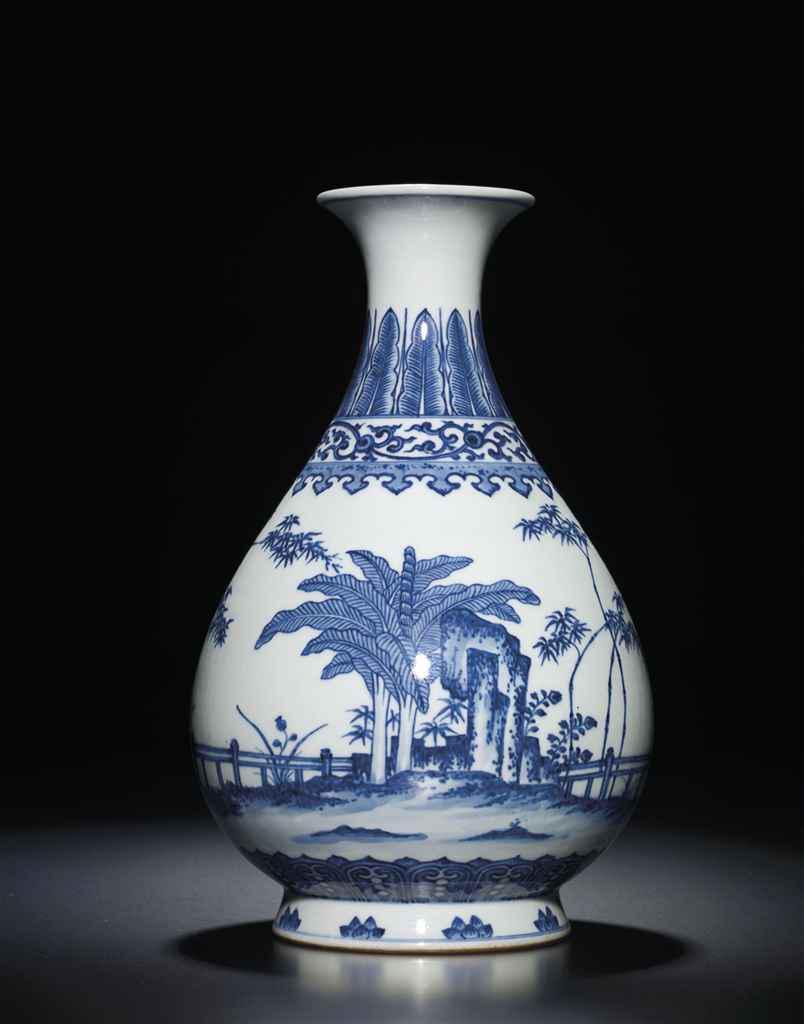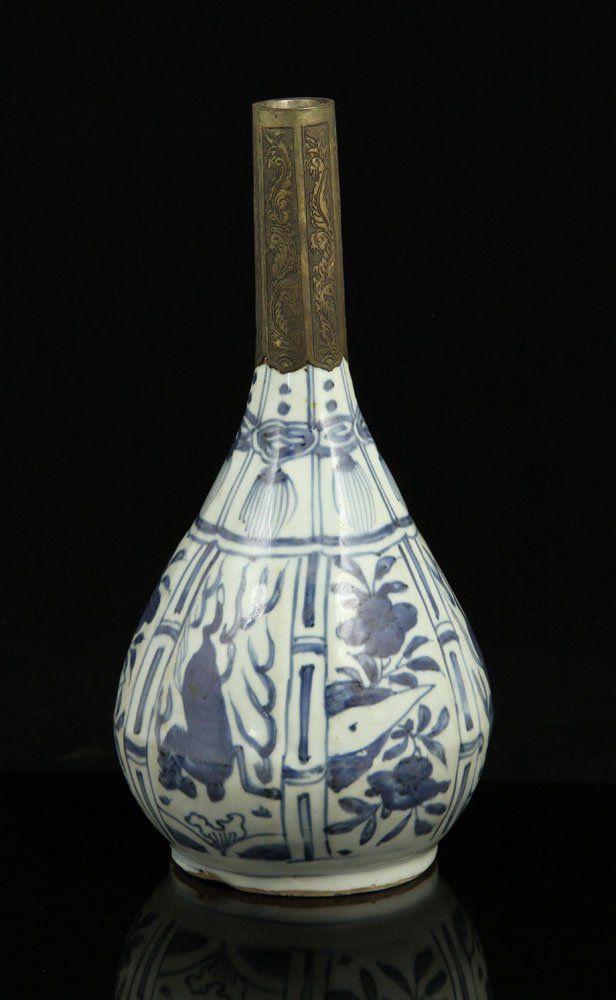The first image is the image on the left, the second image is the image on the right. Evaluate the accuracy of this statement regarding the images: "The left image features a vase with a round midsection and a dragon depicted in blue on its front.". Is it true? Answer yes or no. No. The first image is the image on the left, the second image is the image on the right. Analyze the images presented: Is the assertion "In the left image, the artwork appears to include a dragon." valid? Answer yes or no. No. 